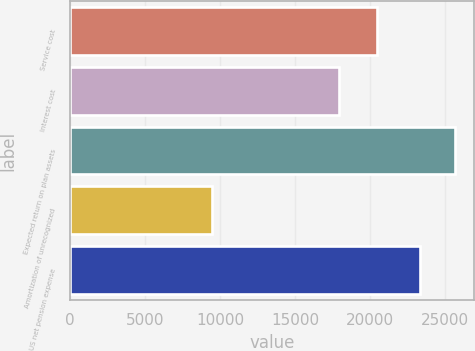Convert chart. <chart><loc_0><loc_0><loc_500><loc_500><bar_chart><fcel>Service cost<fcel>Interest cost<fcel>Expected return on plan assets<fcel>Amortization of unrecognized<fcel>US net pension expense<nl><fcel>20460<fcel>17941<fcel>25627.7<fcel>9492<fcel>23345<nl></chart> 